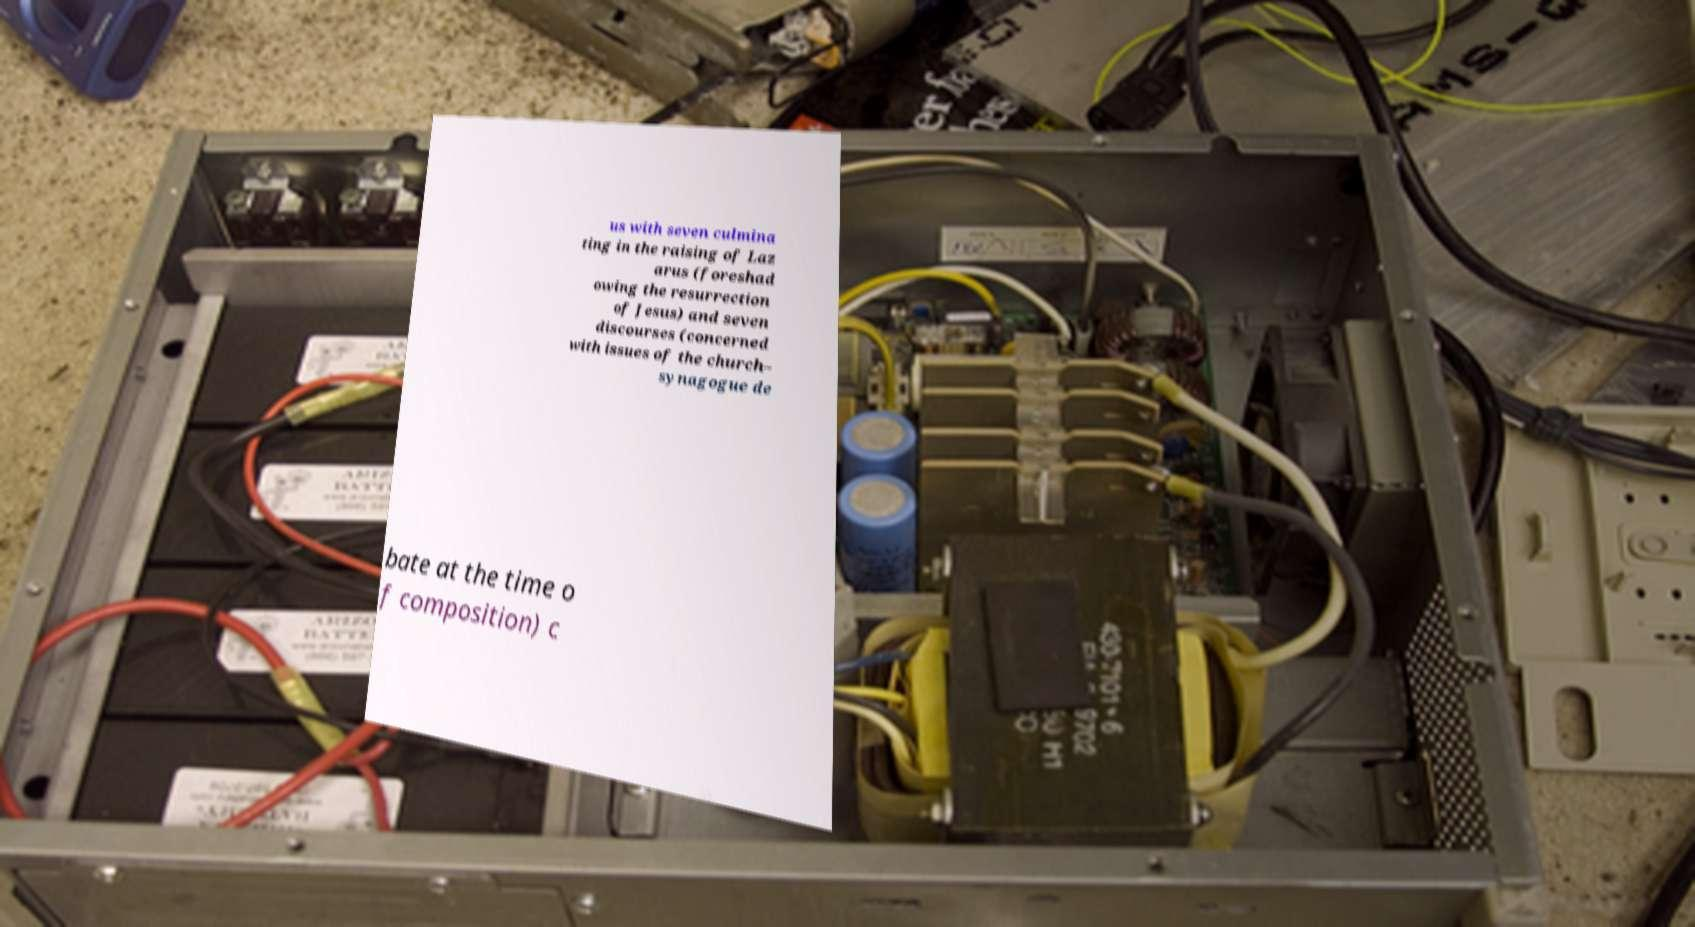I need the written content from this picture converted into text. Can you do that? us with seven culmina ting in the raising of Laz arus (foreshad owing the resurrection of Jesus) and seven discourses (concerned with issues of the church– synagogue de bate at the time o f composition) c 